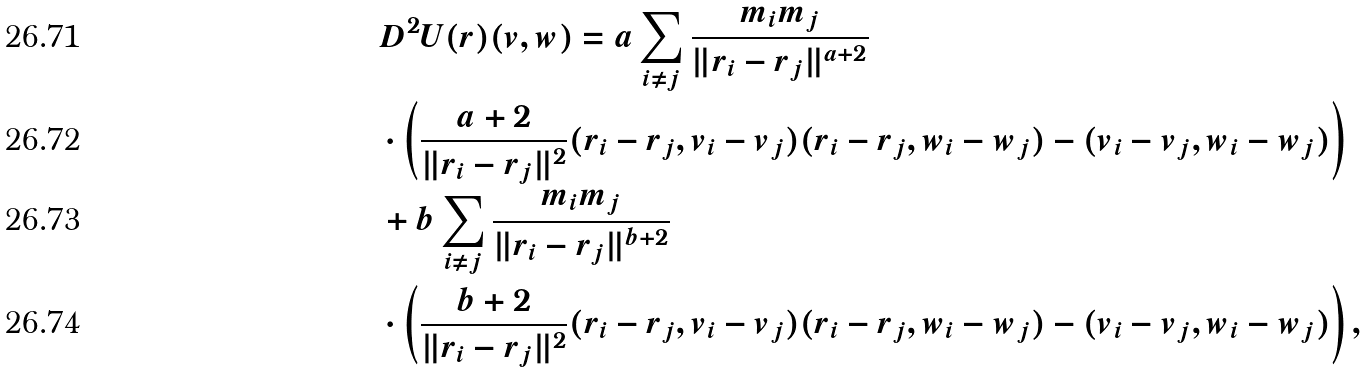Convert formula to latex. <formula><loc_0><loc_0><loc_500><loc_500>& D ^ { 2 } U ( { r } ) ( { v } , { w } ) = a \sum _ { i \neq j } \frac { m _ { i } m _ { j } } { \| { r } _ { i } - { r } _ { j } \| ^ { a + 2 } } \\ & \cdot \left ( \frac { a + 2 } { \| { r } _ { i } - { r } _ { j } \| ^ { 2 } } ( { r } _ { i } - { r } _ { j } , { v } _ { i } - { v } _ { j } ) ( { r } _ { i } - { r } _ { j } , { w } _ { i } - { w } _ { j } ) - ( { v } _ { i } - { v } _ { j } , { w } _ { i } - { w } _ { j } ) \right ) \\ & + b \sum _ { i \neq j } \frac { m _ { i } m _ { j } } { \| { r } _ { i } - { r } _ { j } \| ^ { b + 2 } } \\ & \cdot \left ( \frac { b + 2 } { \| { r } _ { i } - { r } _ { j } \| ^ { 2 } } ( { r } _ { i } - { r } _ { j } , { v } _ { i } - { v } _ { j } ) ( { r } _ { i } - { r } _ { j } , { w } _ { i } - { w } _ { j } ) - ( { v } _ { i } - { v } _ { j } , { w } _ { i } - { w } _ { j } ) \right ) ,</formula> 